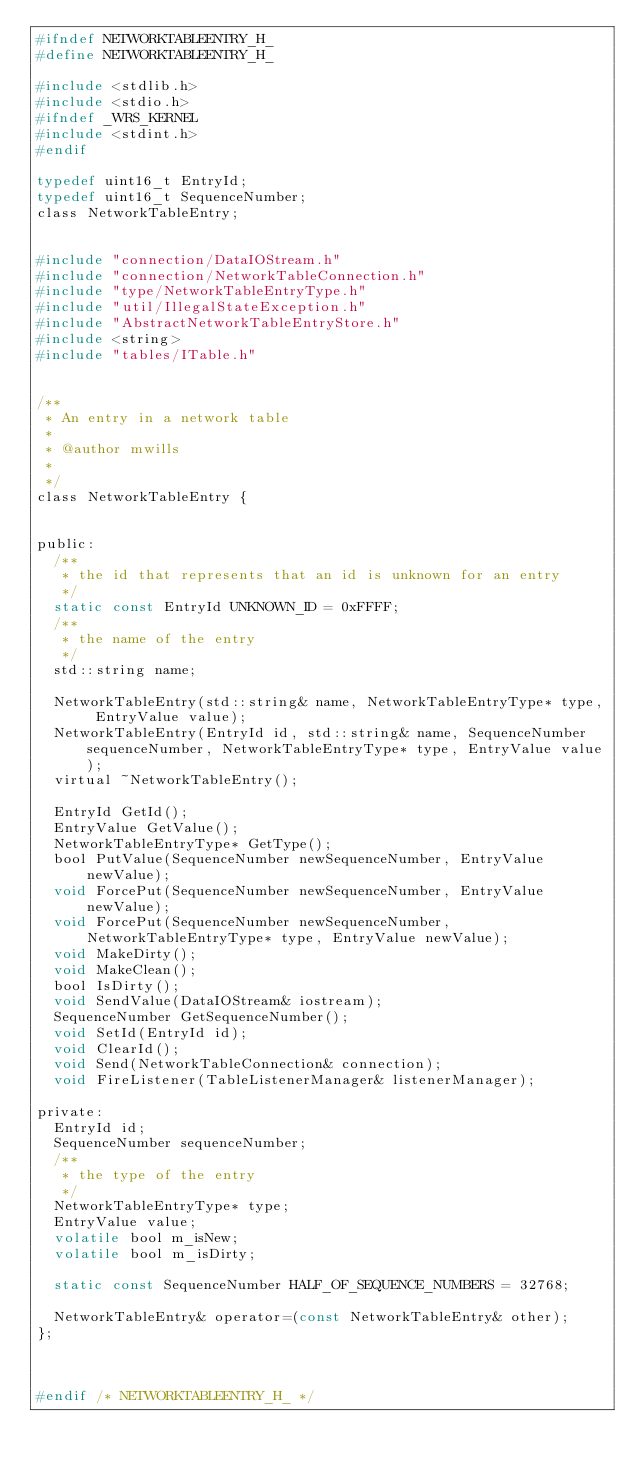<code> <loc_0><loc_0><loc_500><loc_500><_C_>#ifndef NETWORKTABLEENTRY_H_
#define NETWORKTABLEENTRY_H_

#include <stdlib.h>
#include <stdio.h>
#ifndef _WRS_KERNEL
#include <stdint.h>
#endif

typedef uint16_t EntryId;
typedef uint16_t SequenceNumber;
class NetworkTableEntry;


#include "connection/DataIOStream.h"
#include "connection/NetworkTableConnection.h"
#include "type/NetworkTableEntryType.h"
#include "util/IllegalStateException.h"
#include "AbstractNetworkTableEntryStore.h"
#include <string>
#include "tables/ITable.h"


/**
 * An entry in a network table
 * 
 * @author mwills
 *
 */
class NetworkTableEntry {
	

public:
	/**
	 * the id that represents that an id is unknown for an entry
	 */
	static const EntryId UNKNOWN_ID = 0xFFFF;
	/**
	 * the name of the entry
	 */
	std::string name;
	
	NetworkTableEntry(std::string& name, NetworkTableEntryType* type, EntryValue value);
	NetworkTableEntry(EntryId id, std::string& name, SequenceNumber sequenceNumber, NetworkTableEntryType* type, EntryValue value);
	virtual ~NetworkTableEntry();

	EntryId GetId();
	EntryValue GetValue();
	NetworkTableEntryType* GetType();
	bool PutValue(SequenceNumber newSequenceNumber, EntryValue newValue);
	void ForcePut(SequenceNumber newSequenceNumber, EntryValue newValue);
	void ForcePut(SequenceNumber newSequenceNumber, NetworkTableEntryType* type, EntryValue newValue);
	void MakeDirty();
	void MakeClean();
	bool IsDirty();
	void SendValue(DataIOStream& iostream);
	SequenceNumber GetSequenceNumber();
	void SetId(EntryId id);
	void ClearId();
	void Send(NetworkTableConnection& connection);
	void FireListener(TableListenerManager& listenerManager);
	
private:
	EntryId id;
	SequenceNumber sequenceNumber;
	/**
	 * the type of the entry
	 */
	NetworkTableEntryType* type;
	EntryValue value;
	volatile bool m_isNew;
	volatile bool m_isDirty;

	static const SequenceNumber HALF_OF_SEQUENCE_NUMBERS = 32768;

	NetworkTableEntry& operator=(const NetworkTableEntry& other);
};



#endif /* NETWORKTABLEENTRY_H_ */
</code> 